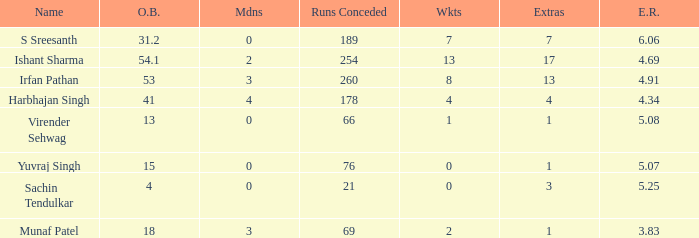Name the runs conceded where overs bowled is 53 1.0. 